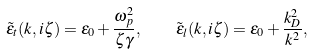<formula> <loc_0><loc_0><loc_500><loc_500>\tilde { \varepsilon } _ { t } ( k , i \zeta ) = \varepsilon _ { 0 } + \frac { \omega _ { p } ^ { 2 } } { \zeta \gamma } , \quad \tilde { \varepsilon } _ { l } ( k , i \zeta ) = \varepsilon _ { 0 } + \frac { k _ { D } ^ { 2 } } { k ^ { 2 } } ,</formula> 